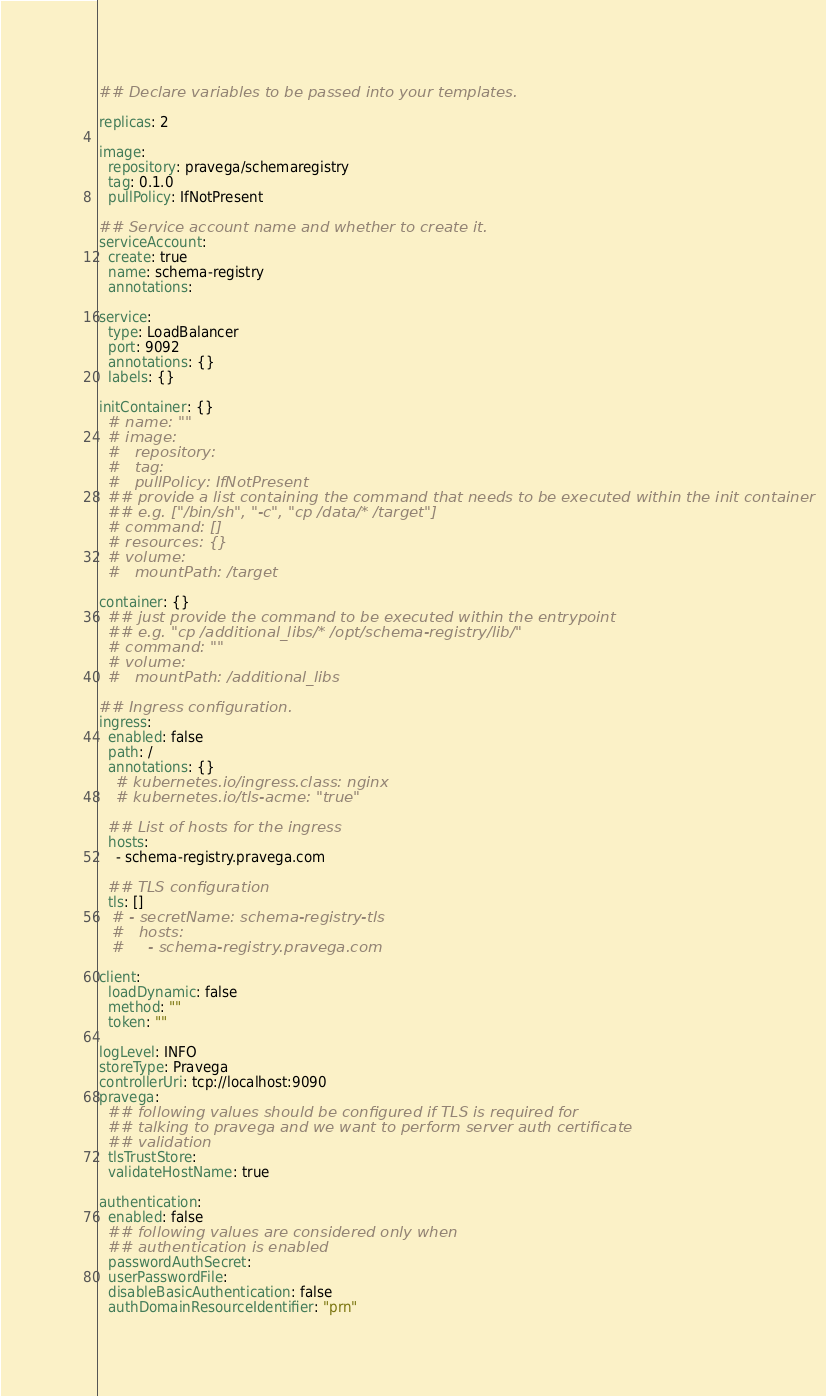Convert code to text. <code><loc_0><loc_0><loc_500><loc_500><_YAML_>## Declare variables to be passed into your templates.

replicas: 2

image:
  repository: pravega/schemaregistry
  tag: 0.1.0
  pullPolicy: IfNotPresent

## Service account name and whether to create it.
serviceAccount:
  create: true
  name: schema-registry
  annotations:

service:
  type: LoadBalancer
  port: 9092
  annotations: {}
  labels: {}

initContainer: {}
  # name: ""
  # image:
  #   repository:
  #   tag:
  #   pullPolicy: IfNotPresent
  ## provide a list containing the command that needs to be executed within the init container
  ## e.g. ["/bin/sh", "-c", "cp /data/* /target"]
  # command: []
  # resources: {}
  # volume:
  #   mountPath: /target

container: {}
  ## just provide the command to be executed within the entrypoint
  ## e.g. "cp /additional_libs/* /opt/schema-registry/lib/"
  # command: ""
  # volume:
  #   mountPath: /additional_libs

## Ingress configuration.
ingress:
  enabled: false
  path: /
  annotations: {}
    # kubernetes.io/ingress.class: nginx
    # kubernetes.io/tls-acme: "true"

  ## List of hosts for the ingress
  hosts:
    - schema-registry.pravega.com

  ## TLS configuration
  tls: []
   # - secretName: schema-registry-tls
   #   hosts:
   #     - schema-registry.pravega.com

client:
  loadDynamic: false
  method: ""
  token: ""

logLevel: INFO
storeType: Pravega
controllerUri: tcp://localhost:9090
pravega:
  ## following values should be configured if TLS is required for
  ## talking to pravega and we want to perform server auth certificate
  ## validation
  tlsTrustStore:
  validateHostName: true

authentication:
  enabled: false
  ## following values are considered only when
  ## authentication is enabled
  passwordAuthSecret:
  userPasswordFile:
  disableBasicAuthentication: false
  authDomainResourceIdentifier: "prn"</code> 